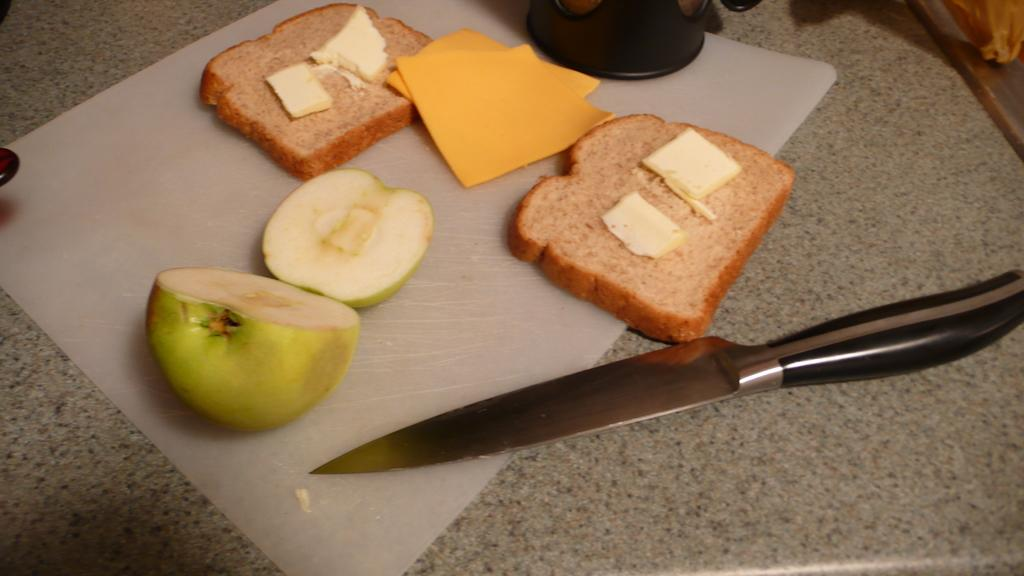What type of utensil is present in the image? There is a knife in the image. What type of food can be seen in the image? There is bread and an apple in the image. Can you describe any other objects present in the image? There are other objects in the image, but their specific details are not mentioned in the provided facts. What type of cook is visible in the image? There is no cook present in the image. What type of trains can be seen in the image? There are no trains present in the image. 